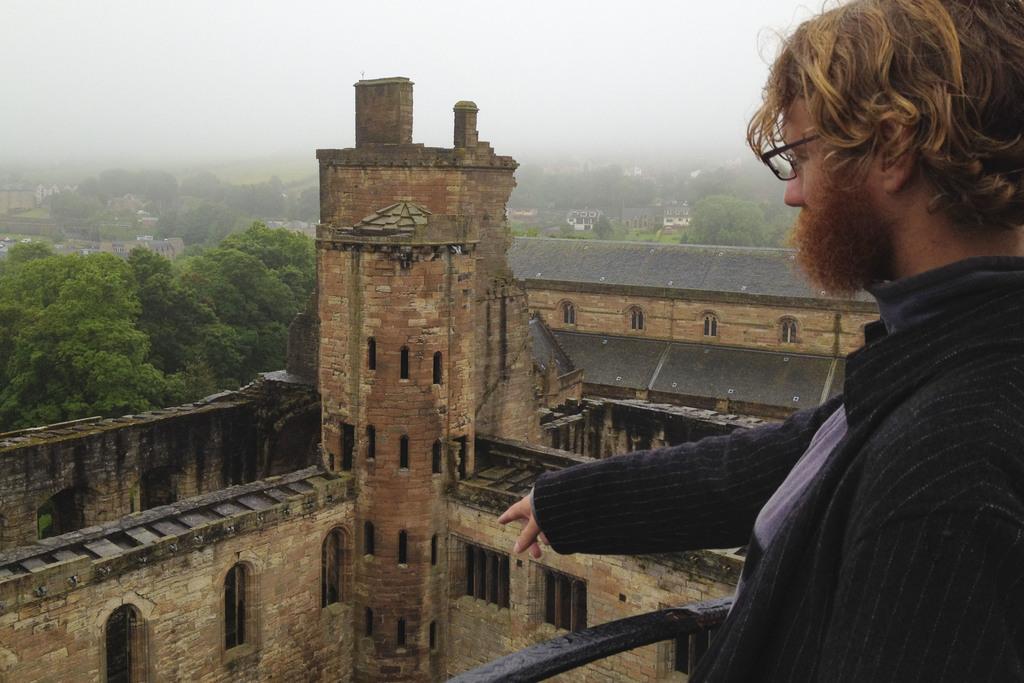How would you summarize this image in a sentence or two? On the right side, there is a person in a suit, wearing a spectacle, standing and watching something. In the background, there are buildings and there are trees on the ground and there is sky. 